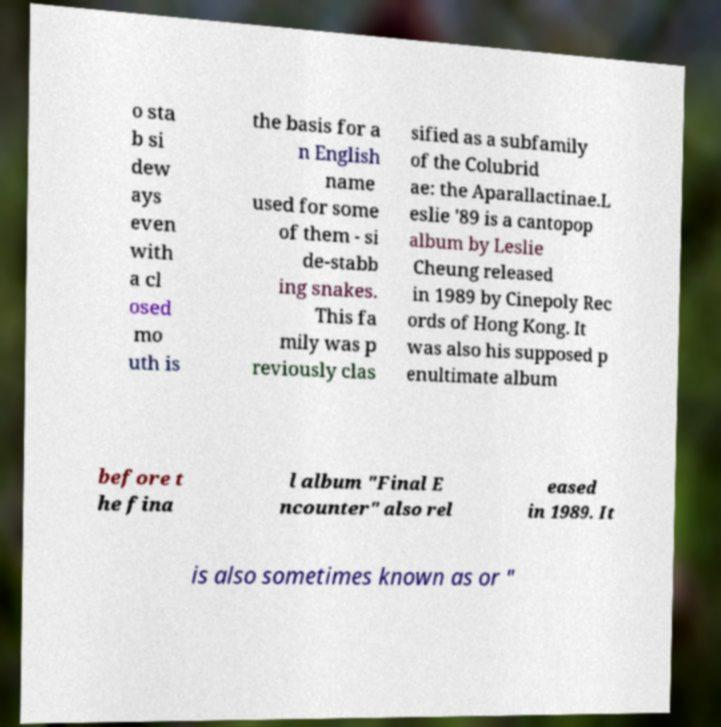Could you assist in decoding the text presented in this image and type it out clearly? o sta b si dew ays even with a cl osed mo uth is the basis for a n English name used for some of them - si de-stabb ing snakes. This fa mily was p reviously clas sified as a subfamily of the Colubrid ae: the Aparallactinae.L eslie '89 is a cantopop album by Leslie Cheung released in 1989 by Cinepoly Rec ords of Hong Kong. It was also his supposed p enultimate album before t he fina l album "Final E ncounter" also rel eased in 1989. It is also sometimes known as or " 